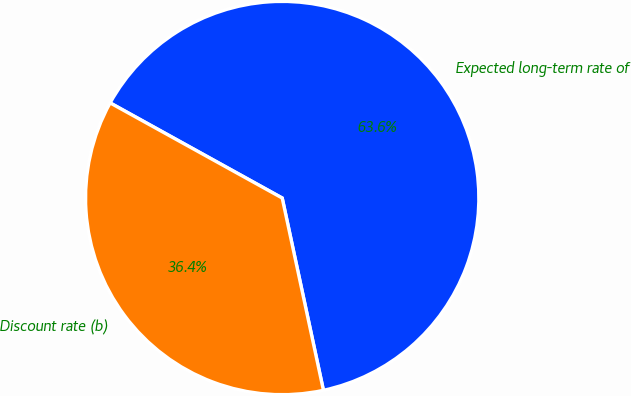<chart> <loc_0><loc_0><loc_500><loc_500><pie_chart><fcel>Expected long-term rate of<fcel>Discount rate (b)<nl><fcel>63.6%<fcel>36.4%<nl></chart> 